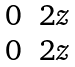<formula> <loc_0><loc_0><loc_500><loc_500>\begin{matrix} 0 & 2 z \\ 0 & 2 z \end{matrix}</formula> 